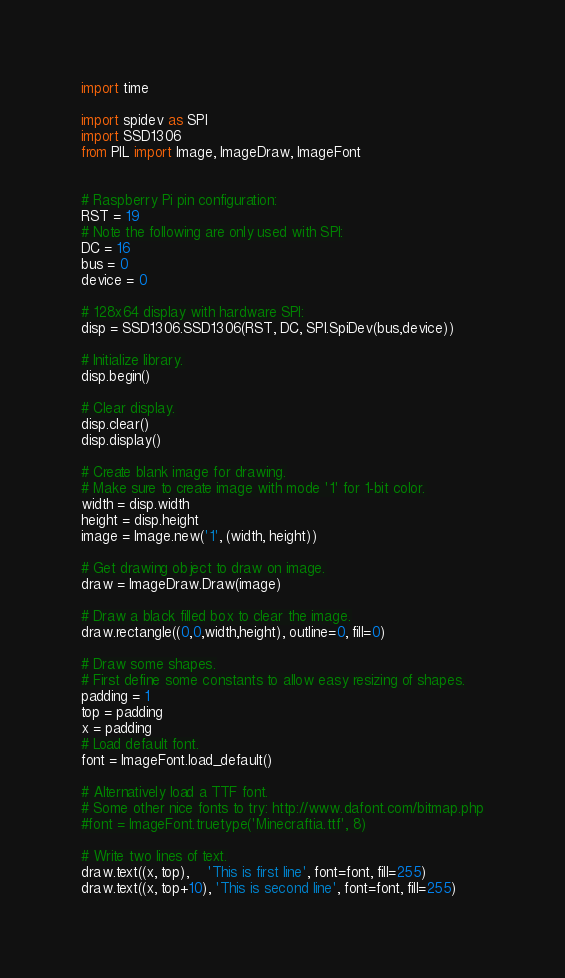<code> <loc_0><loc_0><loc_500><loc_500><_Python_>import time

import spidev as SPI
import SSD1306
from PIL import Image, ImageDraw, ImageFont


# Raspberry Pi pin configuration:
RST = 19
# Note the following are only used with SPI:
DC = 16
bus = 0
device = 0

# 128x64 display with hardware SPI:
disp = SSD1306.SSD1306(RST, DC, SPI.SpiDev(bus,device))

# Initialize library.
disp.begin()

# Clear display.
disp.clear()
disp.display()

# Create blank image for drawing.
# Make sure to create image with mode '1' for 1-bit color.
width = disp.width
height = disp.height
image = Image.new('1', (width, height))

# Get drawing object to draw on image.
draw = ImageDraw.Draw(image)

# Draw a black filled box to clear the image.
draw.rectangle((0,0,width,height), outline=0, fill=0)

# Draw some shapes.
# First define some constants to allow easy resizing of shapes.
padding = 1
top = padding
x = padding
# Load default font.
font = ImageFont.load_default()

# Alternatively load a TTF font.
# Some other nice fonts to try: http://www.dafont.com/bitmap.php
#font = ImageFont.truetype('Minecraftia.ttf', 8)

# Write two lines of text.
draw.text((x, top),    'This is first line', font=font, fill=255)
draw.text((x, top+10), 'This is second line', font=font, fill=255)</code> 